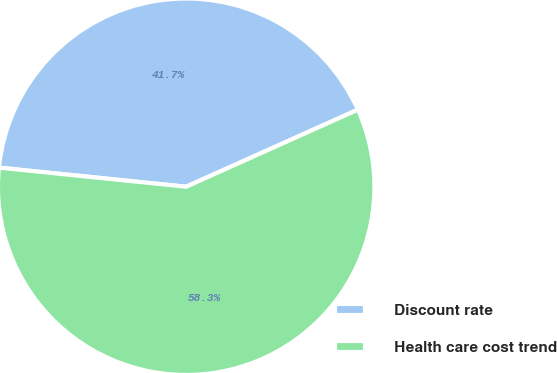<chart> <loc_0><loc_0><loc_500><loc_500><pie_chart><fcel>Discount rate<fcel>Health care cost trend<nl><fcel>41.67%<fcel>58.33%<nl></chart> 